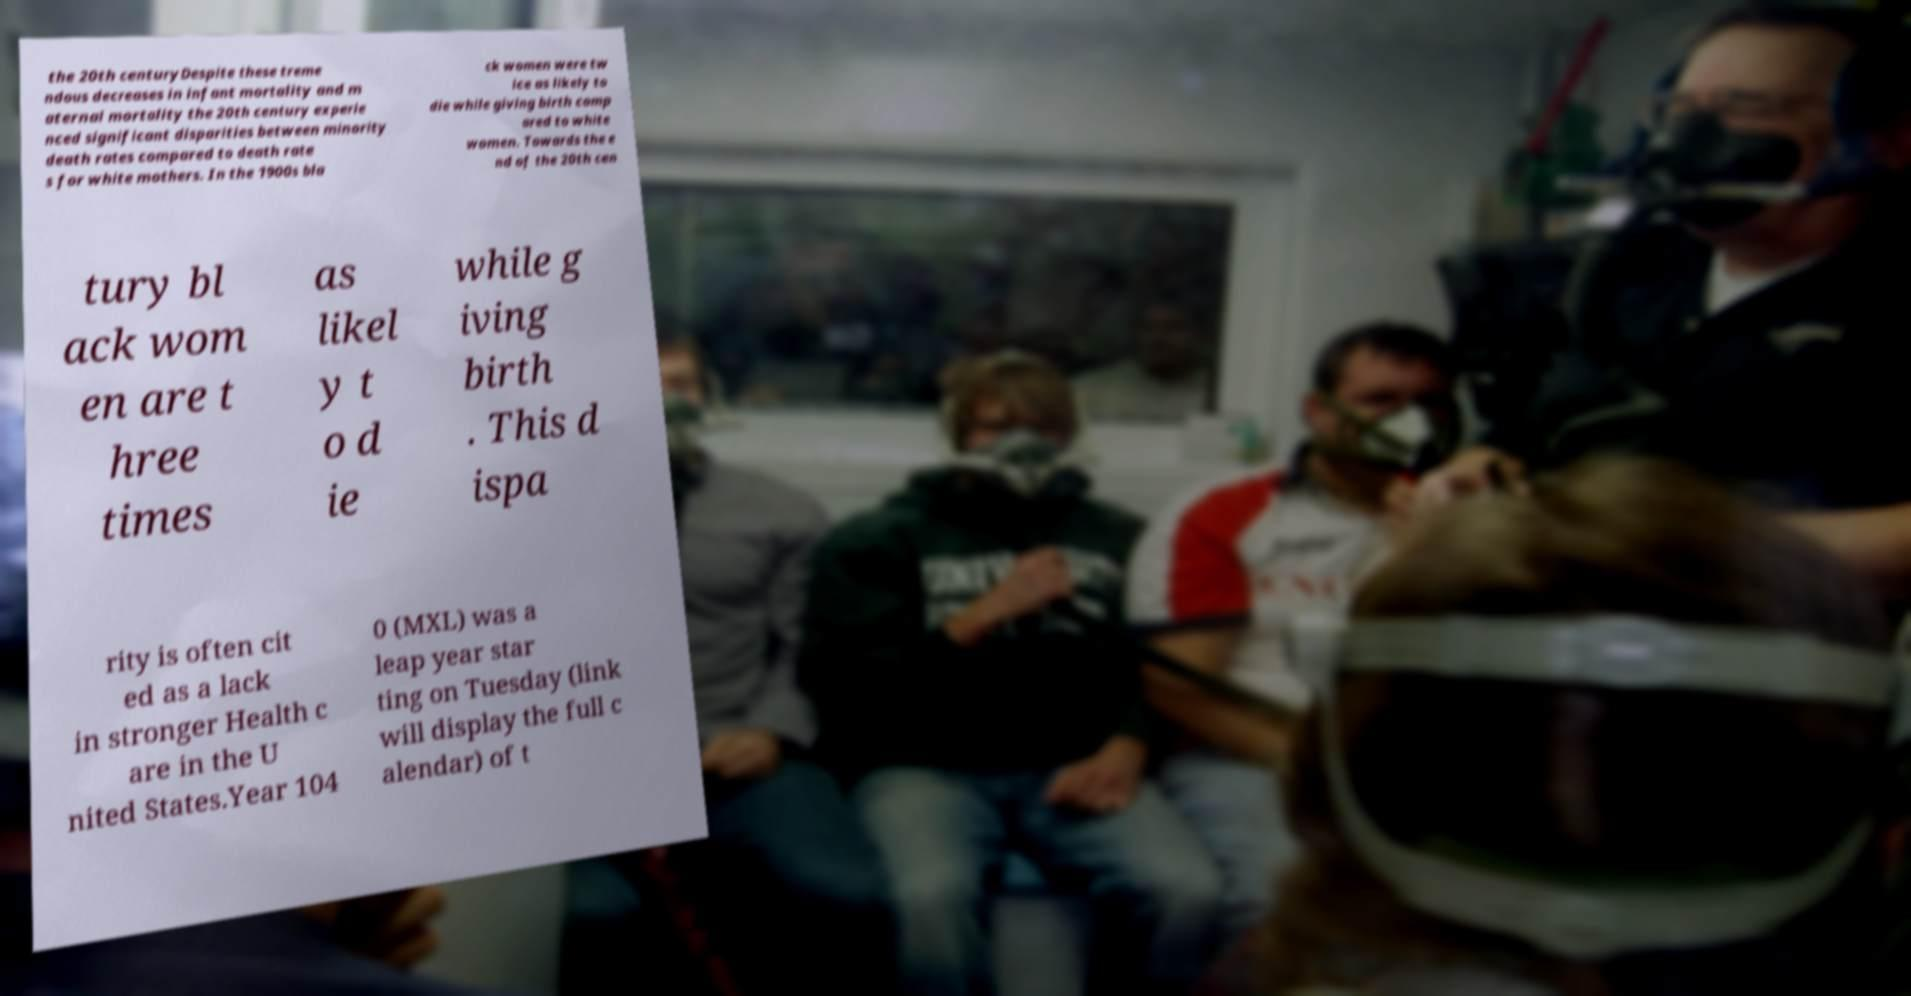Please read and relay the text visible in this image. What does it say? the 20th centuryDespite these treme ndous decreases in infant mortality and m aternal mortality the 20th century experie nced significant disparities between minority death rates compared to death rate s for white mothers. In the 1900s bla ck women were tw ice as likely to die while giving birth comp ared to white women. Towards the e nd of the 20th cen tury bl ack wom en are t hree times as likel y t o d ie while g iving birth . This d ispa rity is often cit ed as a lack in stronger Health c are in the U nited States.Year 104 0 (MXL) was a leap year star ting on Tuesday (link will display the full c alendar) of t 